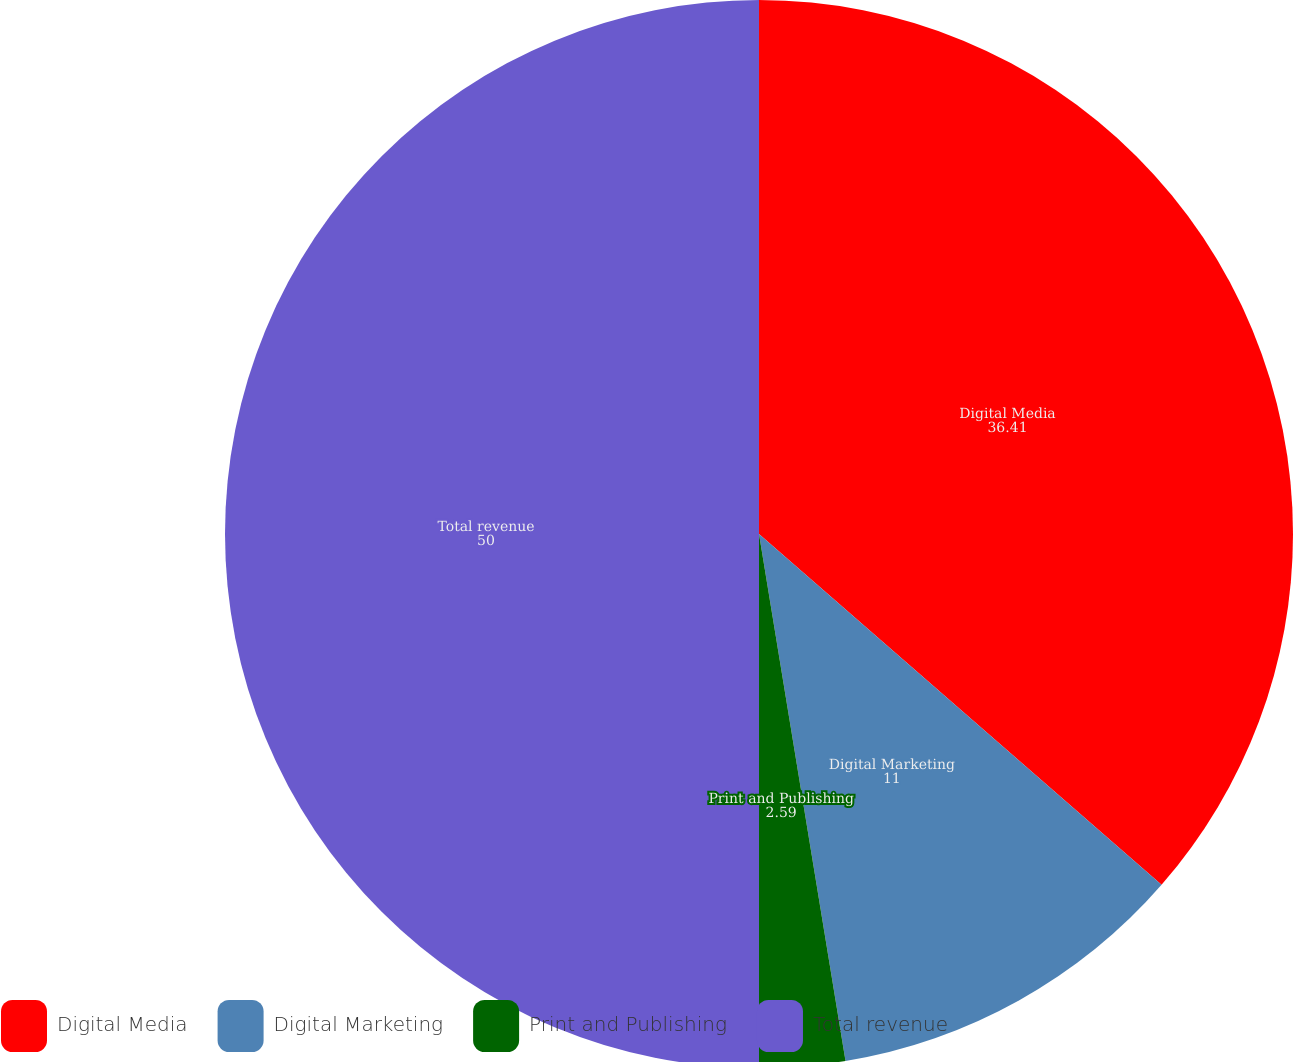Convert chart to OTSL. <chart><loc_0><loc_0><loc_500><loc_500><pie_chart><fcel>Digital Media<fcel>Digital Marketing<fcel>Print and Publishing<fcel>Total revenue<nl><fcel>36.41%<fcel>11.0%<fcel>2.59%<fcel>50.0%<nl></chart> 